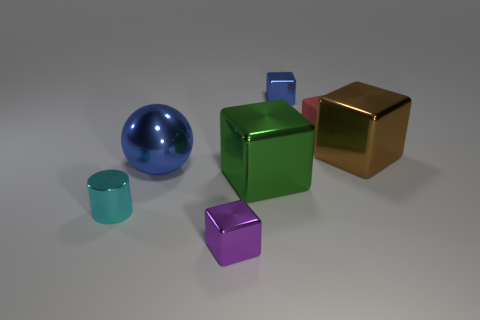How many small metallic things are in front of the big metal cube to the right of the shiny object that is behind the large brown shiny cube?
Your response must be concise. 2. What material is the other big object that is the same shape as the brown metal object?
Make the answer very short. Metal. There is a cube that is behind the purple metal object and in front of the brown shiny block; what material is it?
Your answer should be very brief. Metal. Are there fewer brown objects that are behind the large brown block than green things that are to the left of the purple metallic thing?
Your answer should be compact. No. What number of other things are the same size as the metal cylinder?
Make the answer very short. 3. The thing that is left of the blue shiny object that is left of the small cube that is in front of the small red matte block is what shape?
Your answer should be very brief. Cylinder. How many cyan objects are either tiny things or cylinders?
Your response must be concise. 1. How many blue metal objects are on the left side of the small metal block that is left of the green shiny object?
Give a very brief answer. 1. Is there any other thing that is the same color as the tiny rubber block?
Provide a succinct answer. No. There is a purple object that is the same material as the large sphere; what is its shape?
Your response must be concise. Cube. 